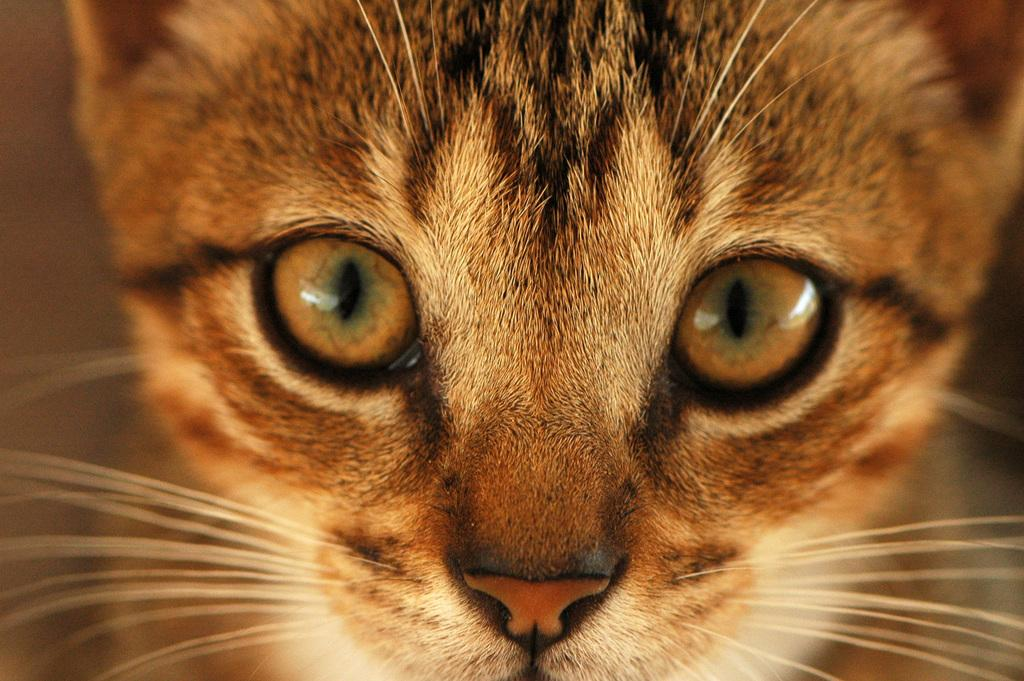What type of animal is in the image? The specific type of animal cannot be determined from the provided facts. Can you describe the background of the image? The background of the image is blurred. What type of wood is used to make the bucket in the image? There is no bucket present in the image, so the type of wood cannot be determined. 